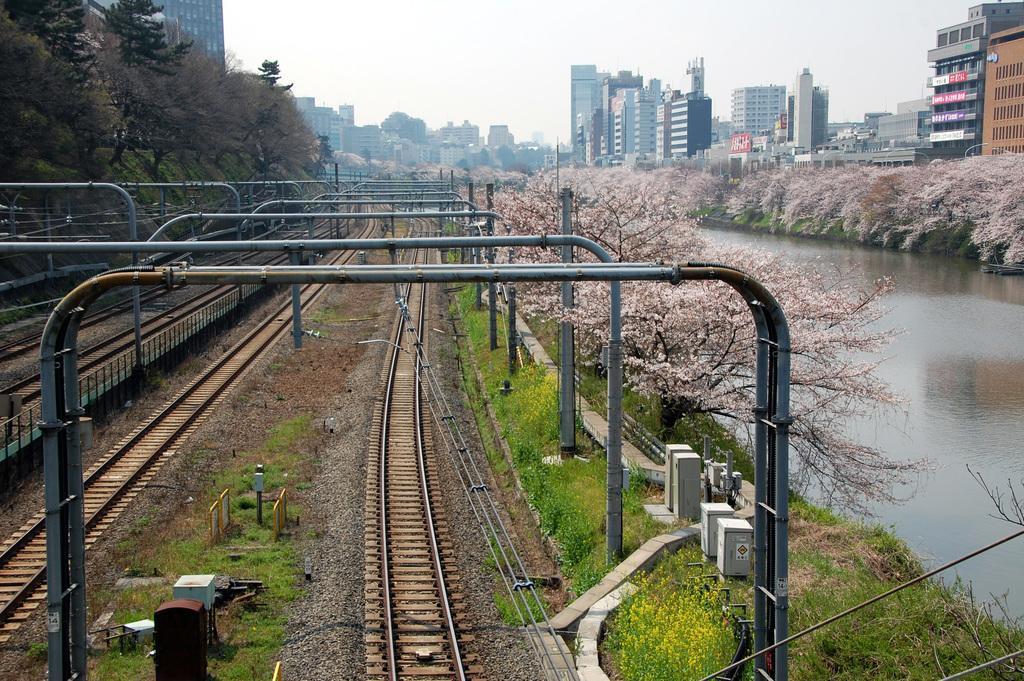How would you summarize this image in a sentence or two? In the image we can see there are railway tracks on the ground and on both the sides there are trees. Beside there is water and behind there are buildings. 